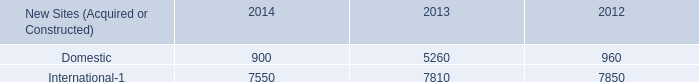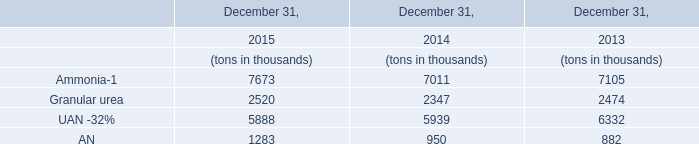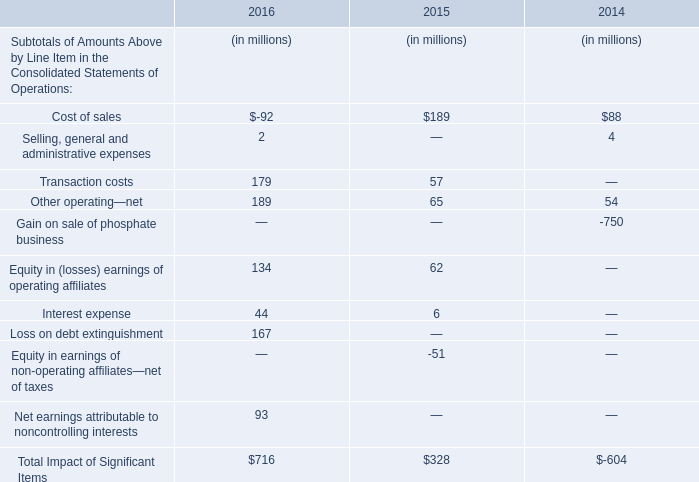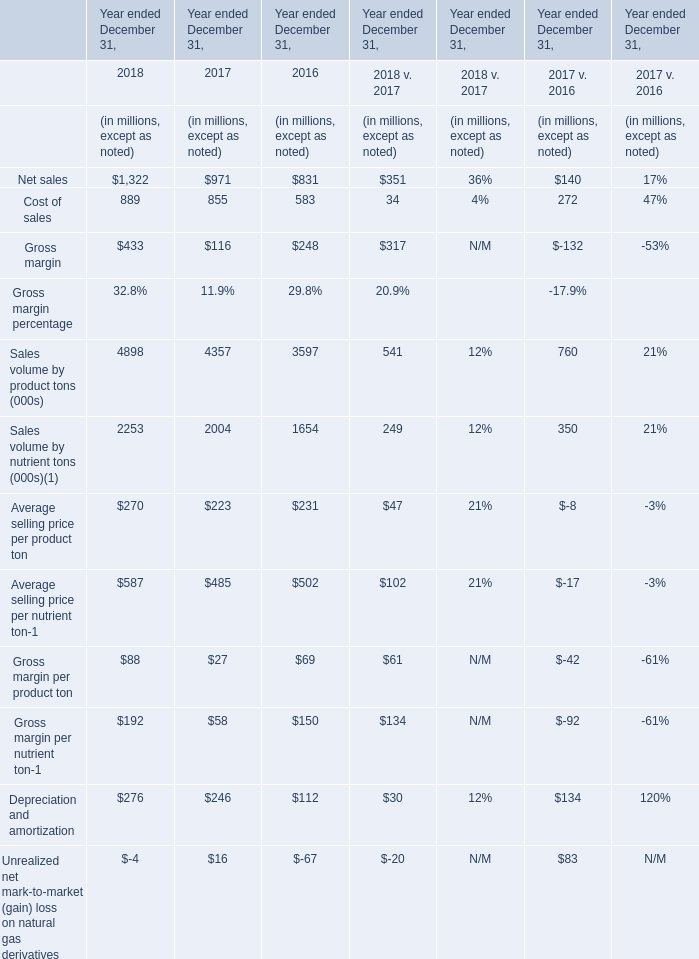What's the average of the Other operating—net in the years where AN for December 31, is greater than 900? (in million) 
Computations: (((189 + 65) + 54) / 3)
Answer: 102.66667. 